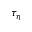<formula> <loc_0><loc_0><loc_500><loc_500>\tau _ { \eta }</formula> 